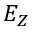Convert formula to latex. <formula><loc_0><loc_0><loc_500><loc_500>E _ { Z }</formula> 